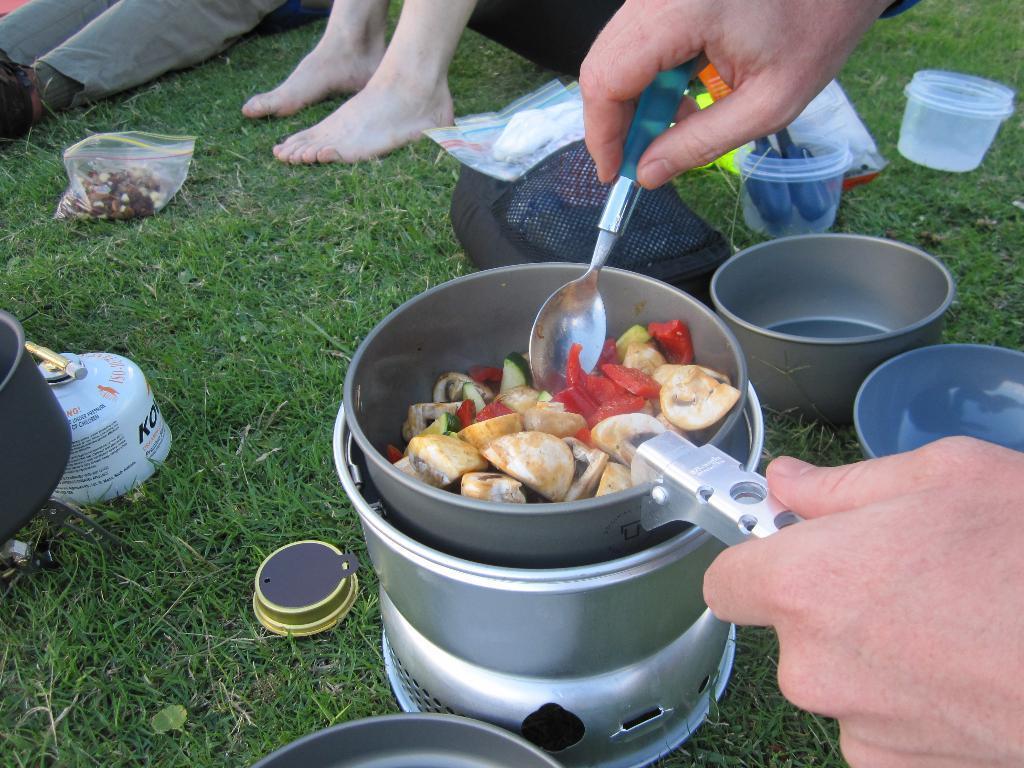How would you summarize this image in a sentence or two? In this picture we can see few people and we can see a person is cooking, we can find few bowls, plastic covers and other things on the grass. 